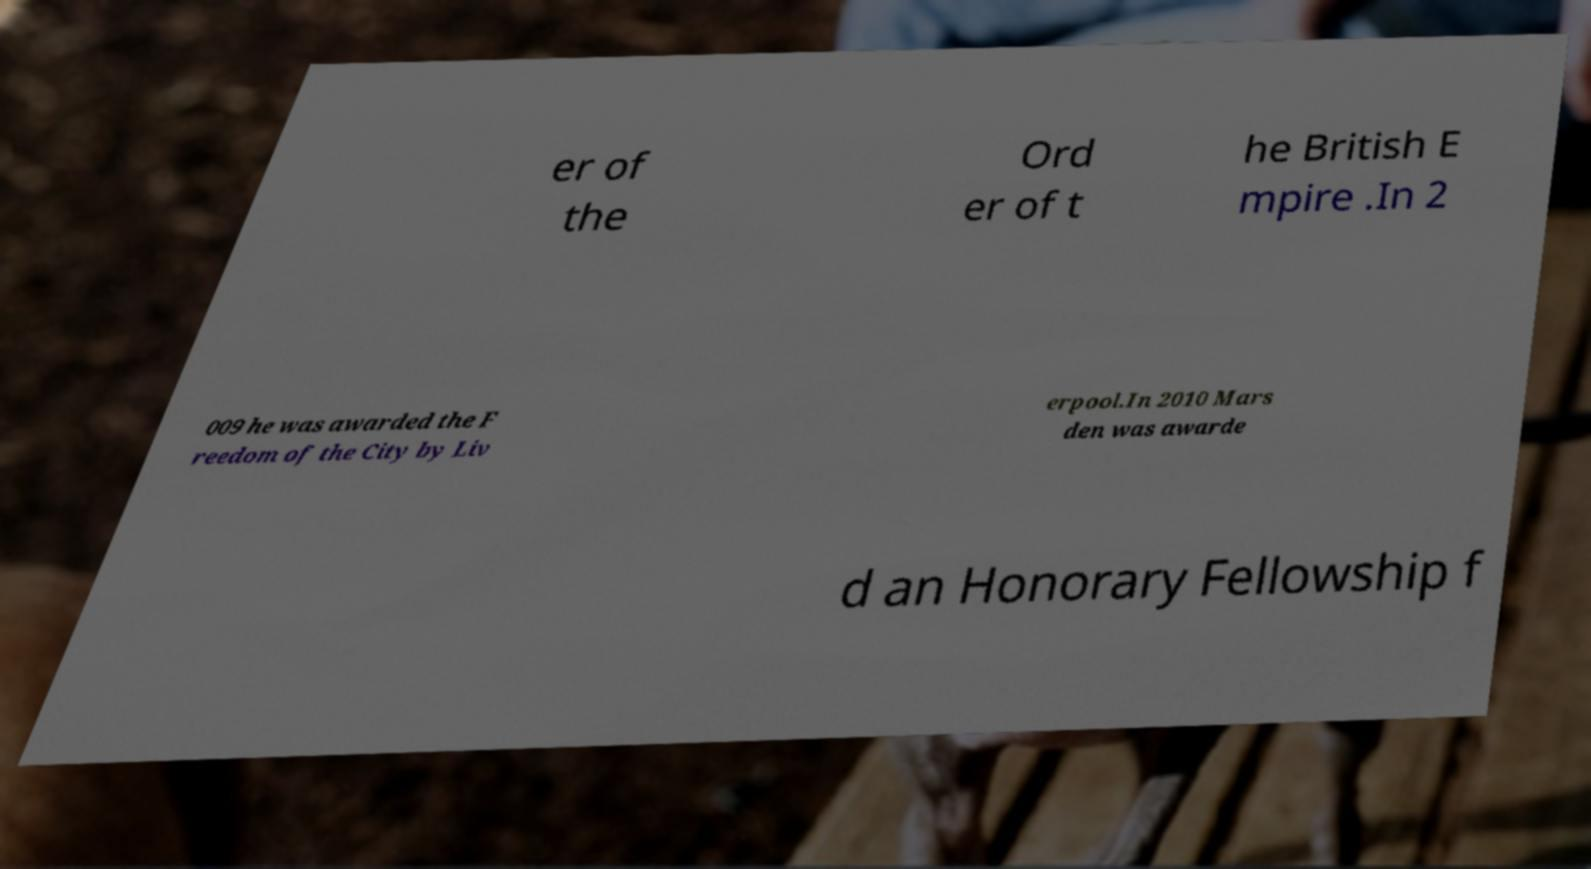Could you extract and type out the text from this image? er of the Ord er of t he British E mpire .In 2 009 he was awarded the F reedom of the City by Liv erpool.In 2010 Mars den was awarde d an Honorary Fellowship f 